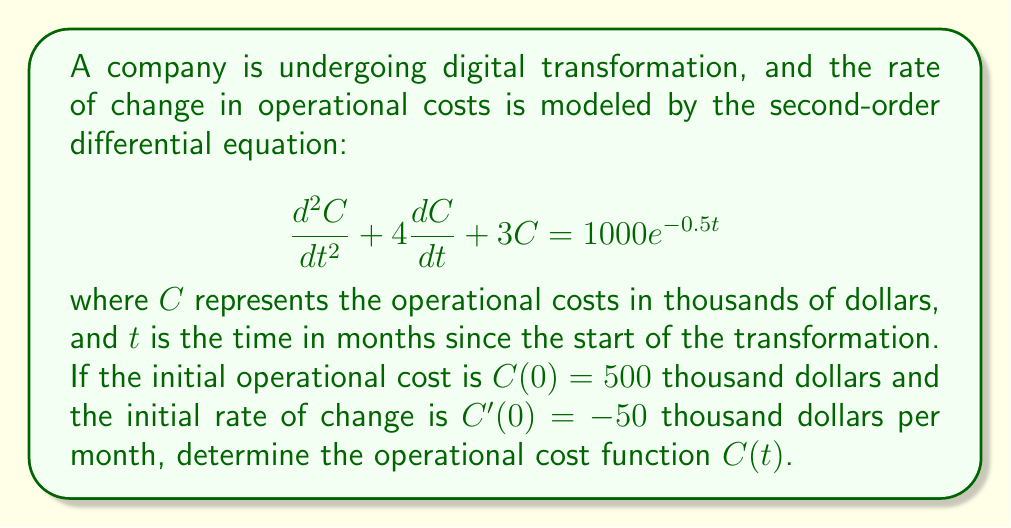Provide a solution to this math problem. To solve this second-order differential equation, we'll follow these steps:

1) First, we identify this as a non-homogeneous linear differential equation with constant coefficients. The general solution will be the sum of the complementary function (solution to the homogeneous equation) and a particular integral.

2) The characteristic equation of the homogeneous part is:
   $$r^2 + 4r + 3 = 0$$
   
   Solving this quadratic equation:
   $$r = \frac{-4 \pm \sqrt{16 - 12}}{2} = \frac{-4 \pm 2}{2}$$
   $$r_1 = -1, r_2 = -3$$

   So the complementary function is:
   $$C_c(t) = A e^{-t} + B e^{-3t}$$

3) For the particular integral, we use the method of undetermined coefficients. Let:
   $$C_p(t) = K e^{-0.5t}$$
   
   Substituting this into the original equation:
   $$(\frac{1}{4}K)e^{-0.5t} + 4(-\frac{1}{2}K)e^{-0.5t} + 3Ke^{-0.5t} = 1000e^{-0.5t}$$
   $$(\frac{1}{4} - 2 + 3)Ke^{-0.5t} = 1000e^{-0.5t}$$
   $$\frac{5}{4}K = 1000$$
   $$K = 800$$

4) The general solution is:
   $$C(t) = A e^{-t} + B e^{-3t} + 800 e^{-0.5t}$$

5) Now we use the initial conditions to find A and B:
   
   $$C(0) = A + B + 800 = 500$$
   $$C'(0) = -A - 3B - 400 = -50$$

   Solving these simultaneously:
   $$A + B = -300$$
   $$A + 3B = 350$$
   
   Subtracting the first equation from the second:
   $$2B = 650$$
   $$B = 325$$
   $$A = -625$$

6) Therefore, the final solution is:
   $$C(t) = -625 e^{-t} + 325 e^{-3t} + 800 e^{-0.5t}$$
Answer: $C(t) = -625 e^{-t} + 325 e^{-3t} + 800 e^{-0.5t}$ 